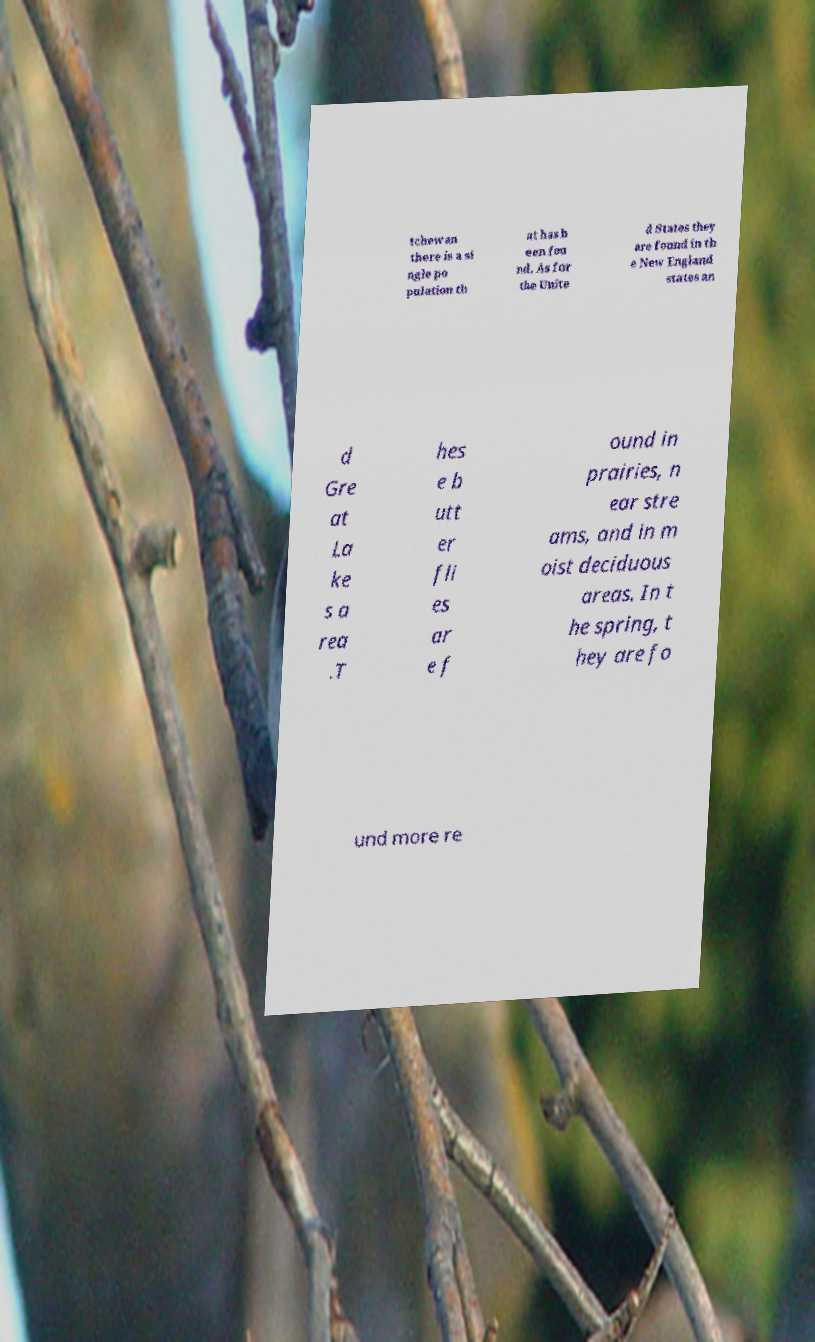Can you read and provide the text displayed in the image?This photo seems to have some interesting text. Can you extract and type it out for me? tchewan there is a si ngle po pulation th at has b een fou nd. As for the Unite d States they are found in th e New England states an d Gre at La ke s a rea .T hes e b utt er fli es ar e f ound in prairies, n ear stre ams, and in m oist deciduous areas. In t he spring, t hey are fo und more re 